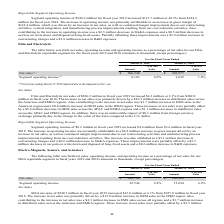According to Kemet Corporation's financial document, What was the main driver of MSA net sales increase between 2018 and 2019? primarily driven by a $15.0 million increase in OEM sales in the JPKO region.. The document states: "2018. The increase in net sales was primarily driven by a $15.0 million increase in OEM sales in the JPKO region. Also contributing to the increase in..." Also, What was the net sales in 2019? According to the financial document, 240,740 (in thousands). The relevant text states: "Net sales $ 240,740 $ 226,964..." Also, Which years does the table provide information for the net sales, operating income, and operating income as a percentage of net sales for the company's MSA segment? The document shows two values: 2019 and 2018. From the document: "March 31, 2019 March 31, 2018 March 31, 2019 March 31, 2018..." Also, can you calculate: What was the change in the percentage to net sales between 2018 and 2019? Based on the calculation: 9.4-6.9, the result is 2.5 (percentage). This is based on the information: "Segment operating income 22,546 9.4% 15,694 6.9% Segment operating income 22,546 9.4% 15,694 6.9%..." The key data points involved are: 6.9, 9.4. Additionally, Which years did net sales exceed $200,000 thousand? The document shows two values: 2019 and 2018. From the document: "March 31, 2019 March 31, 2018 March 31, 2019 March 31, 2018..." Also, can you calculate: What was the percentage change in segment operating income between 2018 and 2019? To answer this question, I need to perform calculations using the financial data. The calculation is: (22,546-15,694)/15,694, which equals 43.66 (percentage). This is based on the information: "Segment operating income 22,546 9.4% 15,694 6.9% Segment operating income 22,546 9.4% 15,694 6.9%..." The key data points involved are: 15,694, 22,546. 